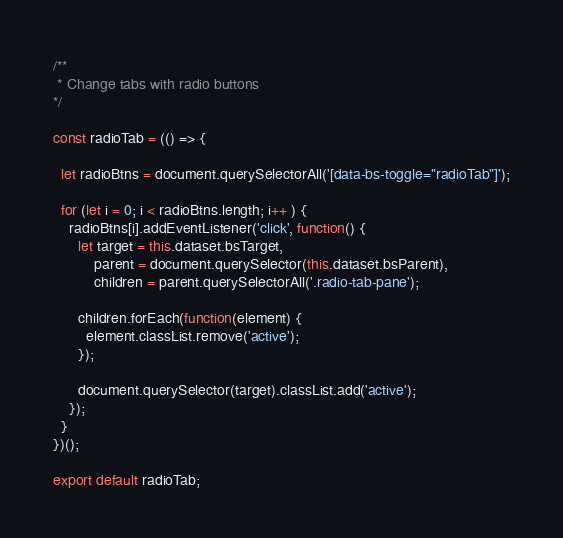<code> <loc_0><loc_0><loc_500><loc_500><_JavaScript_>/**
 * Change tabs with radio buttons
*/

const radioTab = (() => {

  let radioBtns = document.querySelectorAll('[data-bs-toggle="radioTab"]');

  for (let i = 0; i < radioBtns.length; i++ ) {
    radioBtns[i].addEventListener('click', function() {
      let target = this.dataset.bsTarget,
          parent = document.querySelector(this.dataset.bsParent),
          children = parent.querySelectorAll('.radio-tab-pane');

      children.forEach(function(element) {
        element.classList.remove('active');
      });

      document.querySelector(target).classList.add('active');
    });
  }
})();

export default radioTab;
</code> 